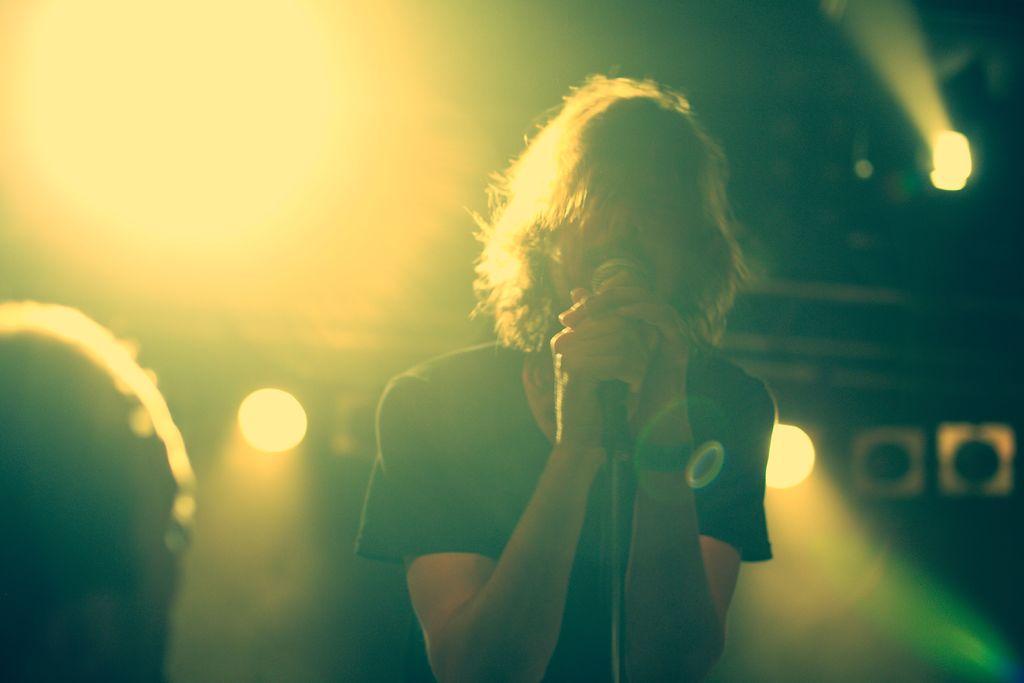Could you give a brief overview of what you see in this image? In this image we can see a man standing holding a mike. On the left side we can see an object. On the backside we can see some lights. 